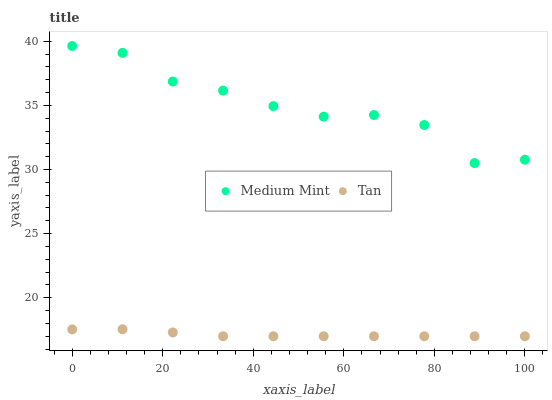Does Tan have the minimum area under the curve?
Answer yes or no. Yes. Does Medium Mint have the maximum area under the curve?
Answer yes or no. Yes. Does Tan have the maximum area under the curve?
Answer yes or no. No. Is Tan the smoothest?
Answer yes or no. Yes. Is Medium Mint the roughest?
Answer yes or no. Yes. Is Tan the roughest?
Answer yes or no. No. Does Tan have the lowest value?
Answer yes or no. Yes. Does Medium Mint have the highest value?
Answer yes or no. Yes. Does Tan have the highest value?
Answer yes or no. No. Is Tan less than Medium Mint?
Answer yes or no. Yes. Is Medium Mint greater than Tan?
Answer yes or no. Yes. Does Tan intersect Medium Mint?
Answer yes or no. No. 